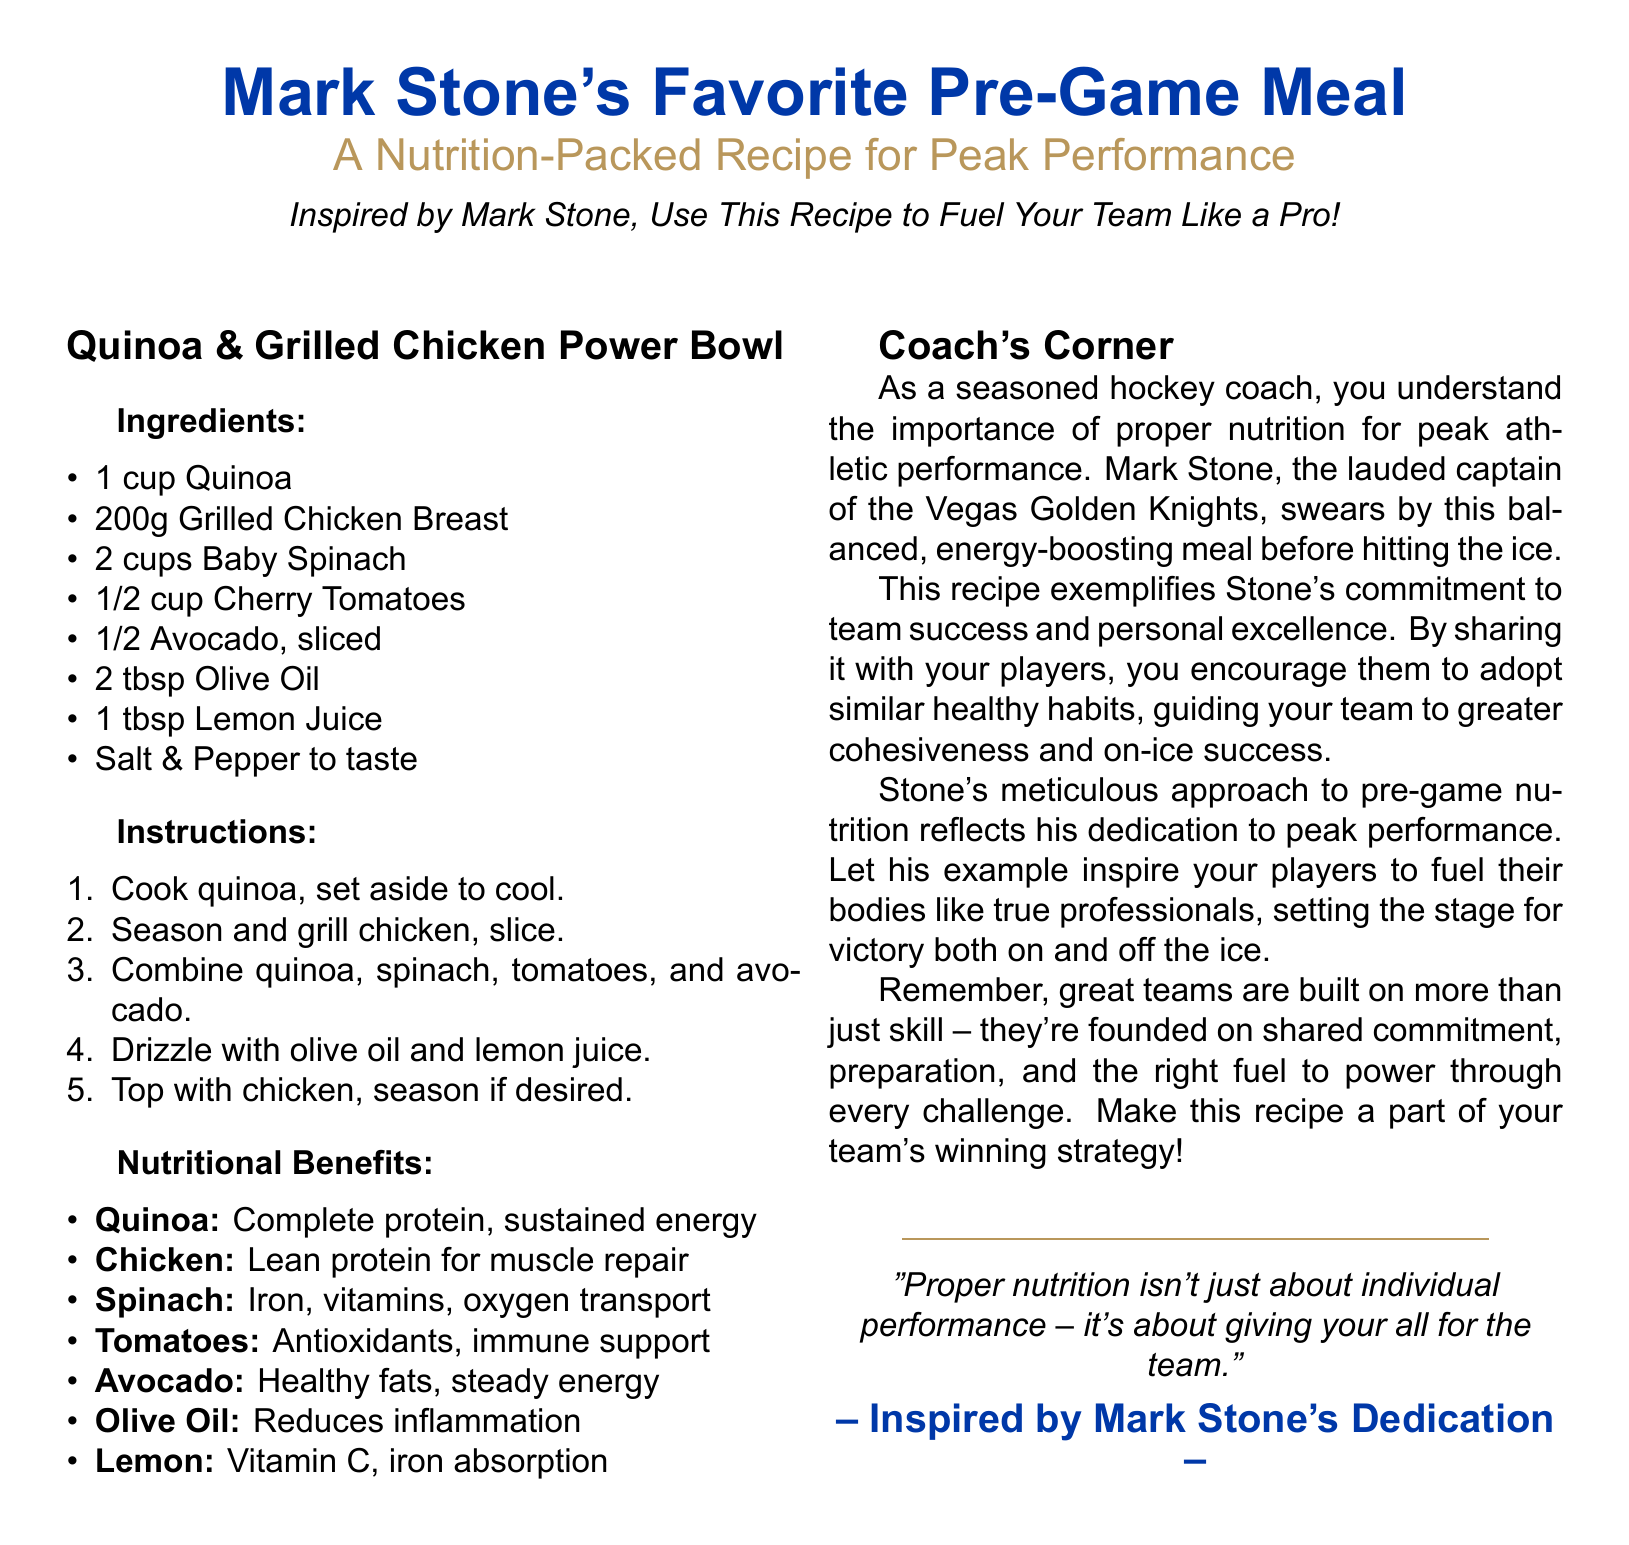What is Mark Stone's favorite pre-game meal? The meal is detailed in the recipe section of the document titled "Mark Stone's Favorite Pre-Game Meal."
Answer: Quinoa & Grilled Chicken Power Bowl How much grilled chicken breast is used in the recipe? The ingredient list specifies the weight of grilled chicken breast needed for the recipe.
Answer: 200g What is the primary benefit of quinoa mentioned? The nutritional benefits section discusses the advantages of each ingredient, highlighting quinoa's specific benefit.
Answer: Complete protein, sustained energy Which ingredient in the recipe is known for healthy fats? The nutritional benefits section lists the advantages of each ingredient, and healthy fats are associated with a specific one.
Answer: Avocado What is the function of olive oil in this meal? The nutritional benefits section describes the role of olive oil within the recipe.
Answer: Reduces inflammation According to the document, what essential nutrient does spinach provide? The benefits of spinach are detailed within the nutritional benefits section, highlighting its contributions.
Answer: Iron, vitamins, oxygen transport What is the key message in the Coach's Corner regarding nutrition? The Coach's Corner summarizes the broader significance of nutrition in performance and teamwork, conveying a motivational message.
Answer: Proper nutrition isn't just about individual performance – it's about giving your all for the team Which ingredient aids in iron absorption? The nutritional benefits list highlights a specific ingredient that improves the absorption of iron in the body.
Answer: Lemon What does the recipe symbolize in relation to Mark Stone's approach? The Coach's Corner section emphasizes what the recipe represents regarding Mark Stone's values and practices.
Answer: Commitment to team success and personal excellence 